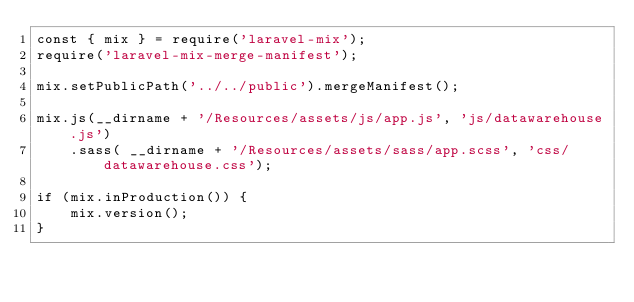Convert code to text. <code><loc_0><loc_0><loc_500><loc_500><_JavaScript_>const { mix } = require('laravel-mix');
require('laravel-mix-merge-manifest');

mix.setPublicPath('../../public').mergeManifest();

mix.js(__dirname + '/Resources/assets/js/app.js', 'js/datawarehouse.js')
    .sass( __dirname + '/Resources/assets/sass/app.scss', 'css/datawarehouse.css');

if (mix.inProduction()) {
    mix.version();
}</code> 